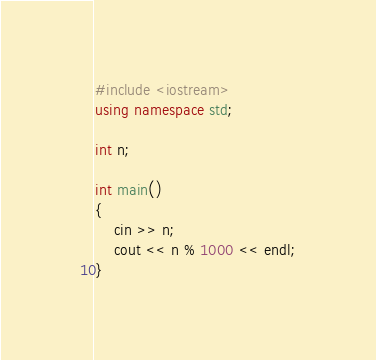<code> <loc_0><loc_0><loc_500><loc_500><_C++_>#include <iostream>
using namespace std;

int n;

int main()
{
  	cin >> n;
	cout << n % 1000 << endl;
}
</code> 